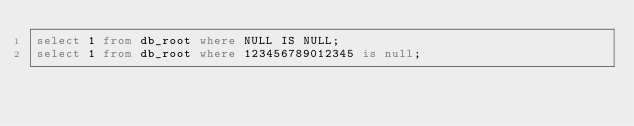Convert code to text. <code><loc_0><loc_0><loc_500><loc_500><_SQL_>select 1 from db_root where NULL IS NULL;
select 1 from db_root where 123456789012345 is null;</code> 